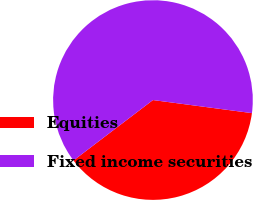Convert chart to OTSL. <chart><loc_0><loc_0><loc_500><loc_500><pie_chart><fcel>Equities<fcel>Fixed income securities<nl><fcel>37.56%<fcel>62.44%<nl></chart> 